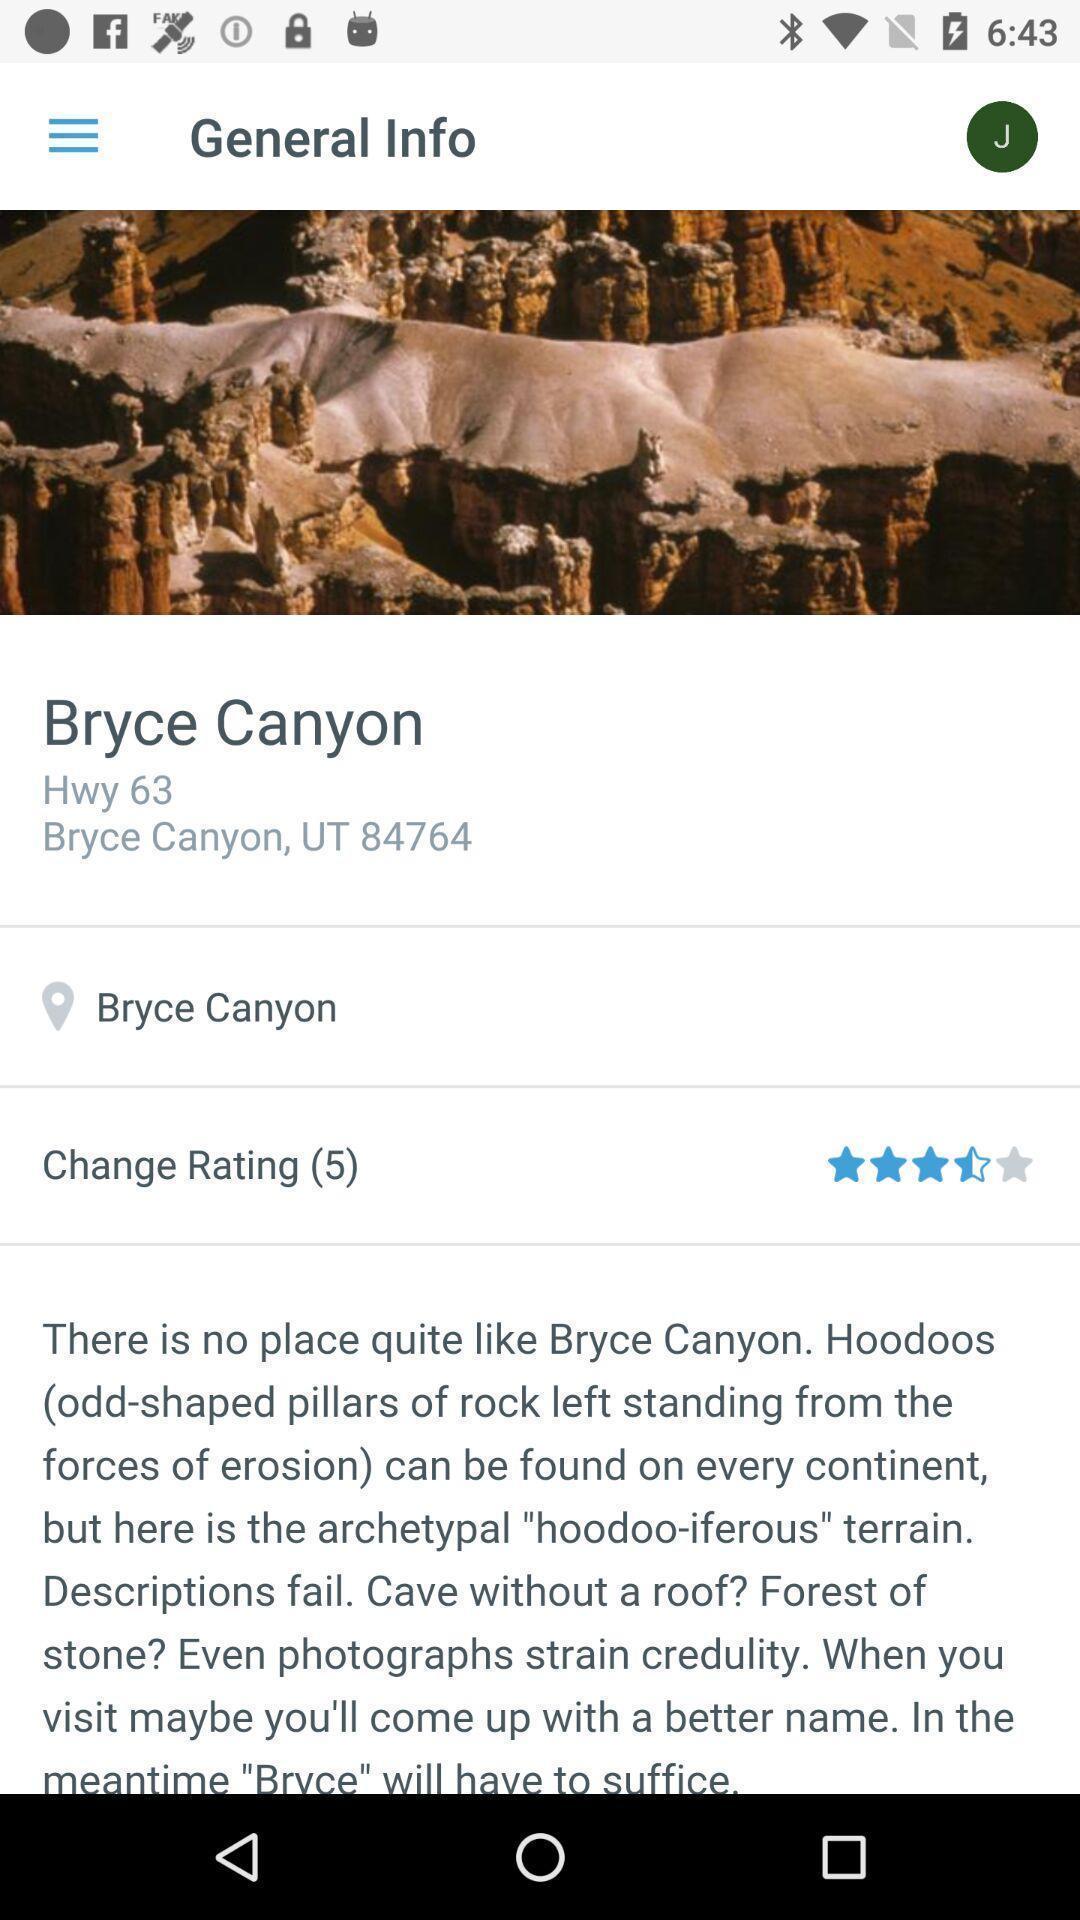What is the overall content of this screenshot? Screen page of a general info about a location. 